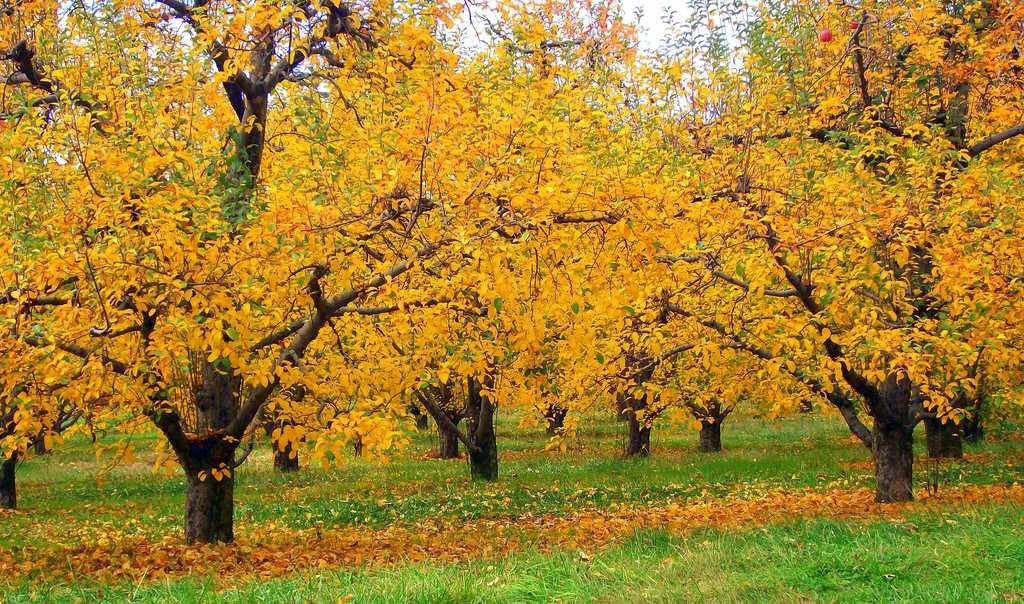What type of surface is visible in the image? The image contains a grass surface. What can be observed about the trees in the image? There are trees with yellow leaves in the image. What part of the natural environment is visible in the image? The sky is visible at the top of the trees in the image. How many bikes are parked near the trees in the image? There are no bikes present in the image. What type of insect can be seen crawling on the grass in the image? There is no insect visible in the image. 